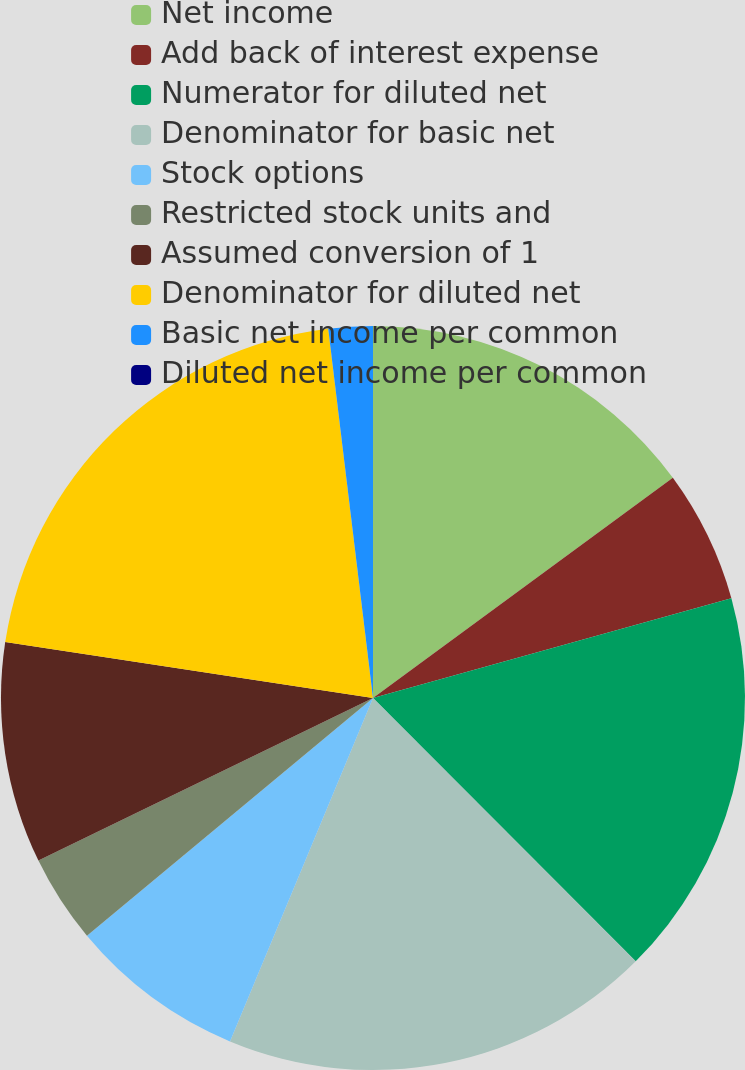Convert chart. <chart><loc_0><loc_0><loc_500><loc_500><pie_chart><fcel>Net income<fcel>Add back of interest expense<fcel>Numerator for diluted net<fcel>Denominator for basic net<fcel>Stock options<fcel>Restricted stock units and<fcel>Assumed conversion of 1<fcel>Denominator for diluted net<fcel>Basic net income per common<fcel>Diluted net income per common<nl><fcel>14.92%<fcel>5.76%<fcel>16.84%<fcel>18.76%<fcel>7.68%<fcel>3.84%<fcel>9.6%<fcel>20.68%<fcel>1.92%<fcel>0.0%<nl></chart> 